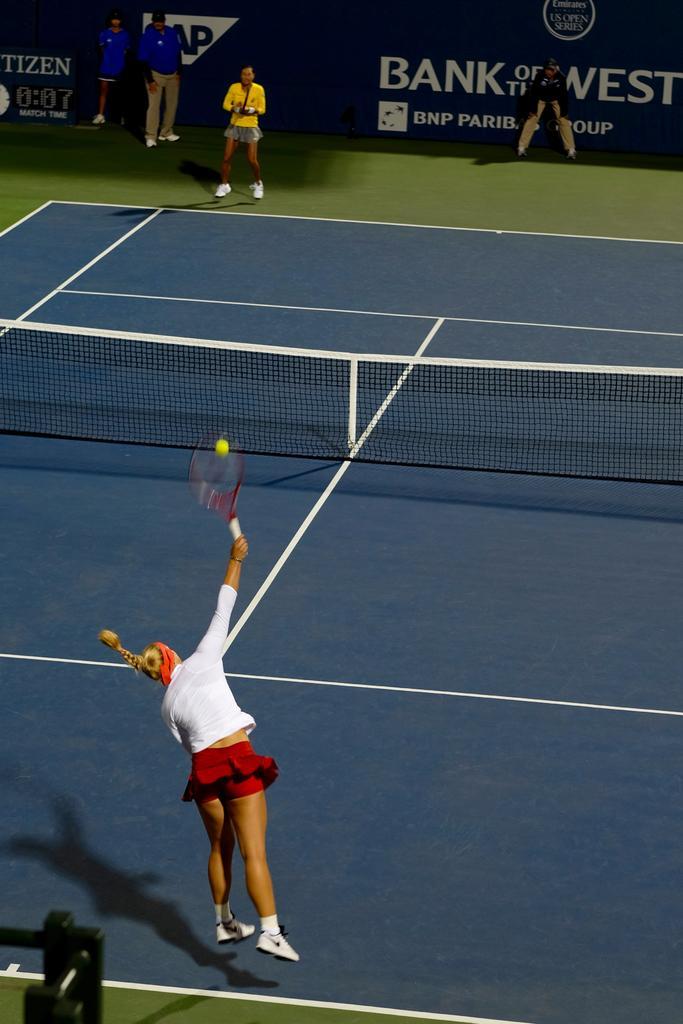Can you describe this image briefly? In this picture we can observe two women playing tennis in the court. One of the woman is wearing a white and red color dress and other woman is wearing yellow color dress. There are some people standing here near the wall. We can observe the net. The court is in blue color. 